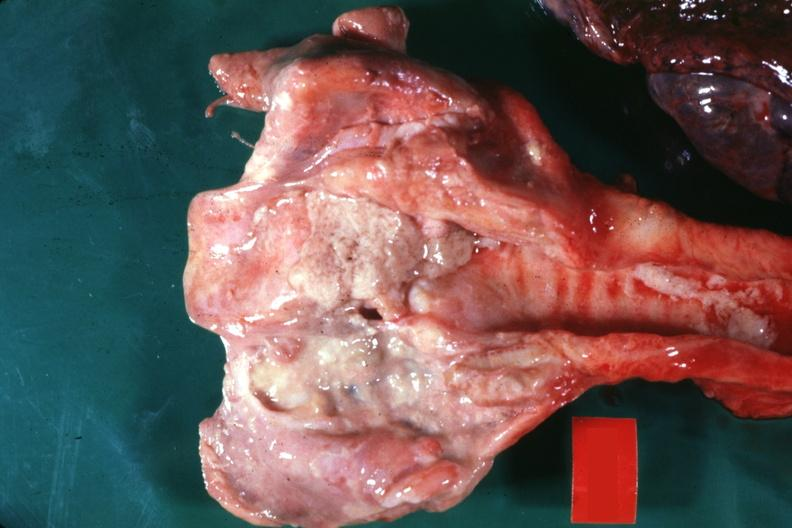what is present?
Answer the question using a single word or phrase. Ulcer 